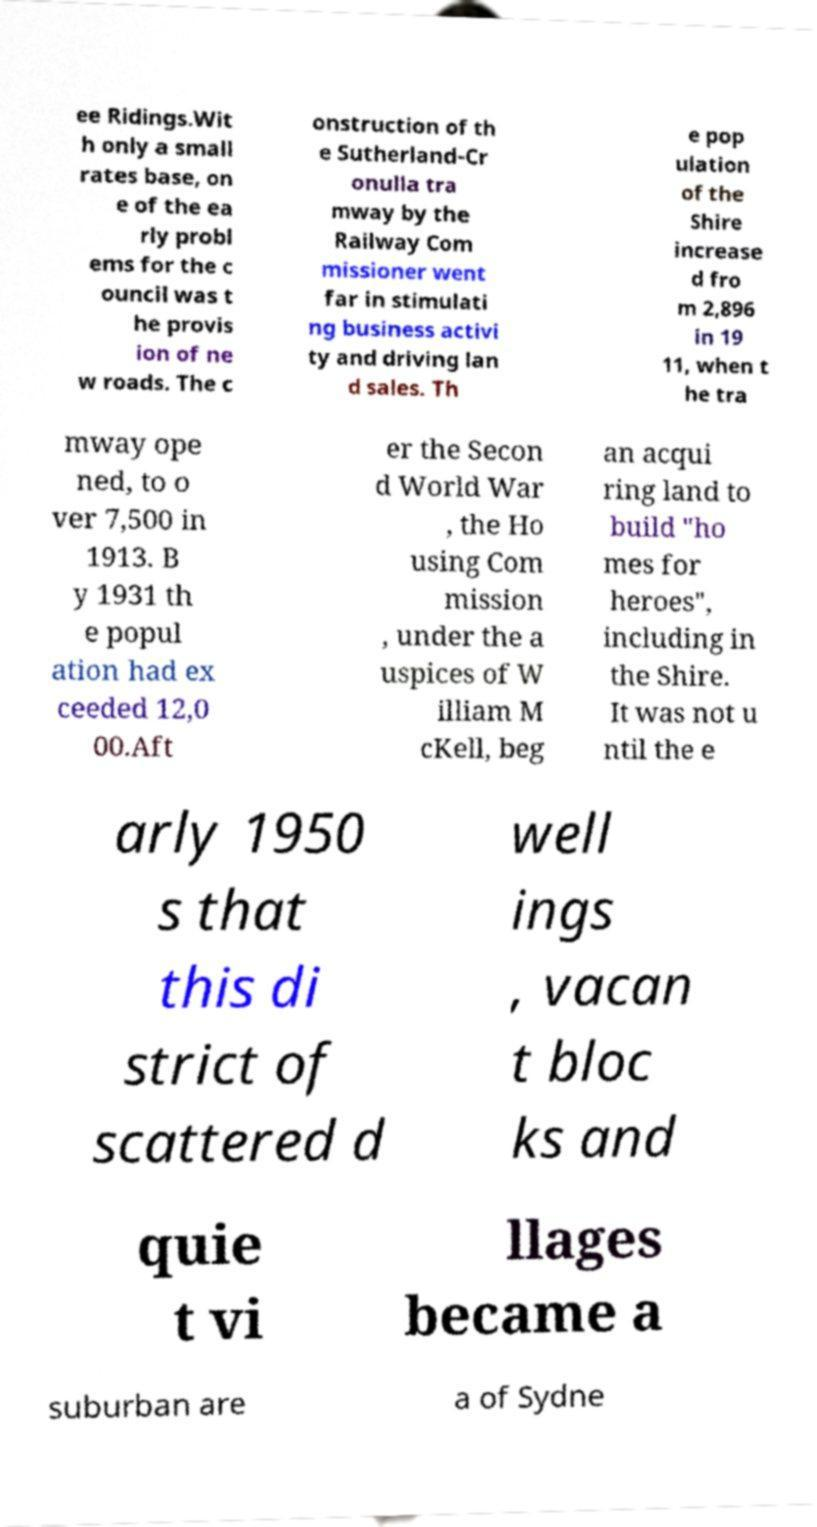Could you assist in decoding the text presented in this image and type it out clearly? ee Ridings.Wit h only a small rates base, on e of the ea rly probl ems for the c ouncil was t he provis ion of ne w roads. The c onstruction of th e Sutherland-Cr onulla tra mway by the Railway Com missioner went far in stimulati ng business activi ty and driving lan d sales. Th e pop ulation of the Shire increase d fro m 2,896 in 19 11, when t he tra mway ope ned, to o ver 7,500 in 1913. B y 1931 th e popul ation had ex ceeded 12,0 00.Aft er the Secon d World War , the Ho using Com mission , under the a uspices of W illiam M cKell, beg an acqui ring land to build "ho mes for heroes", including in the Shire. It was not u ntil the e arly 1950 s that this di strict of scattered d well ings , vacan t bloc ks and quie t vi llages became a suburban are a of Sydne 